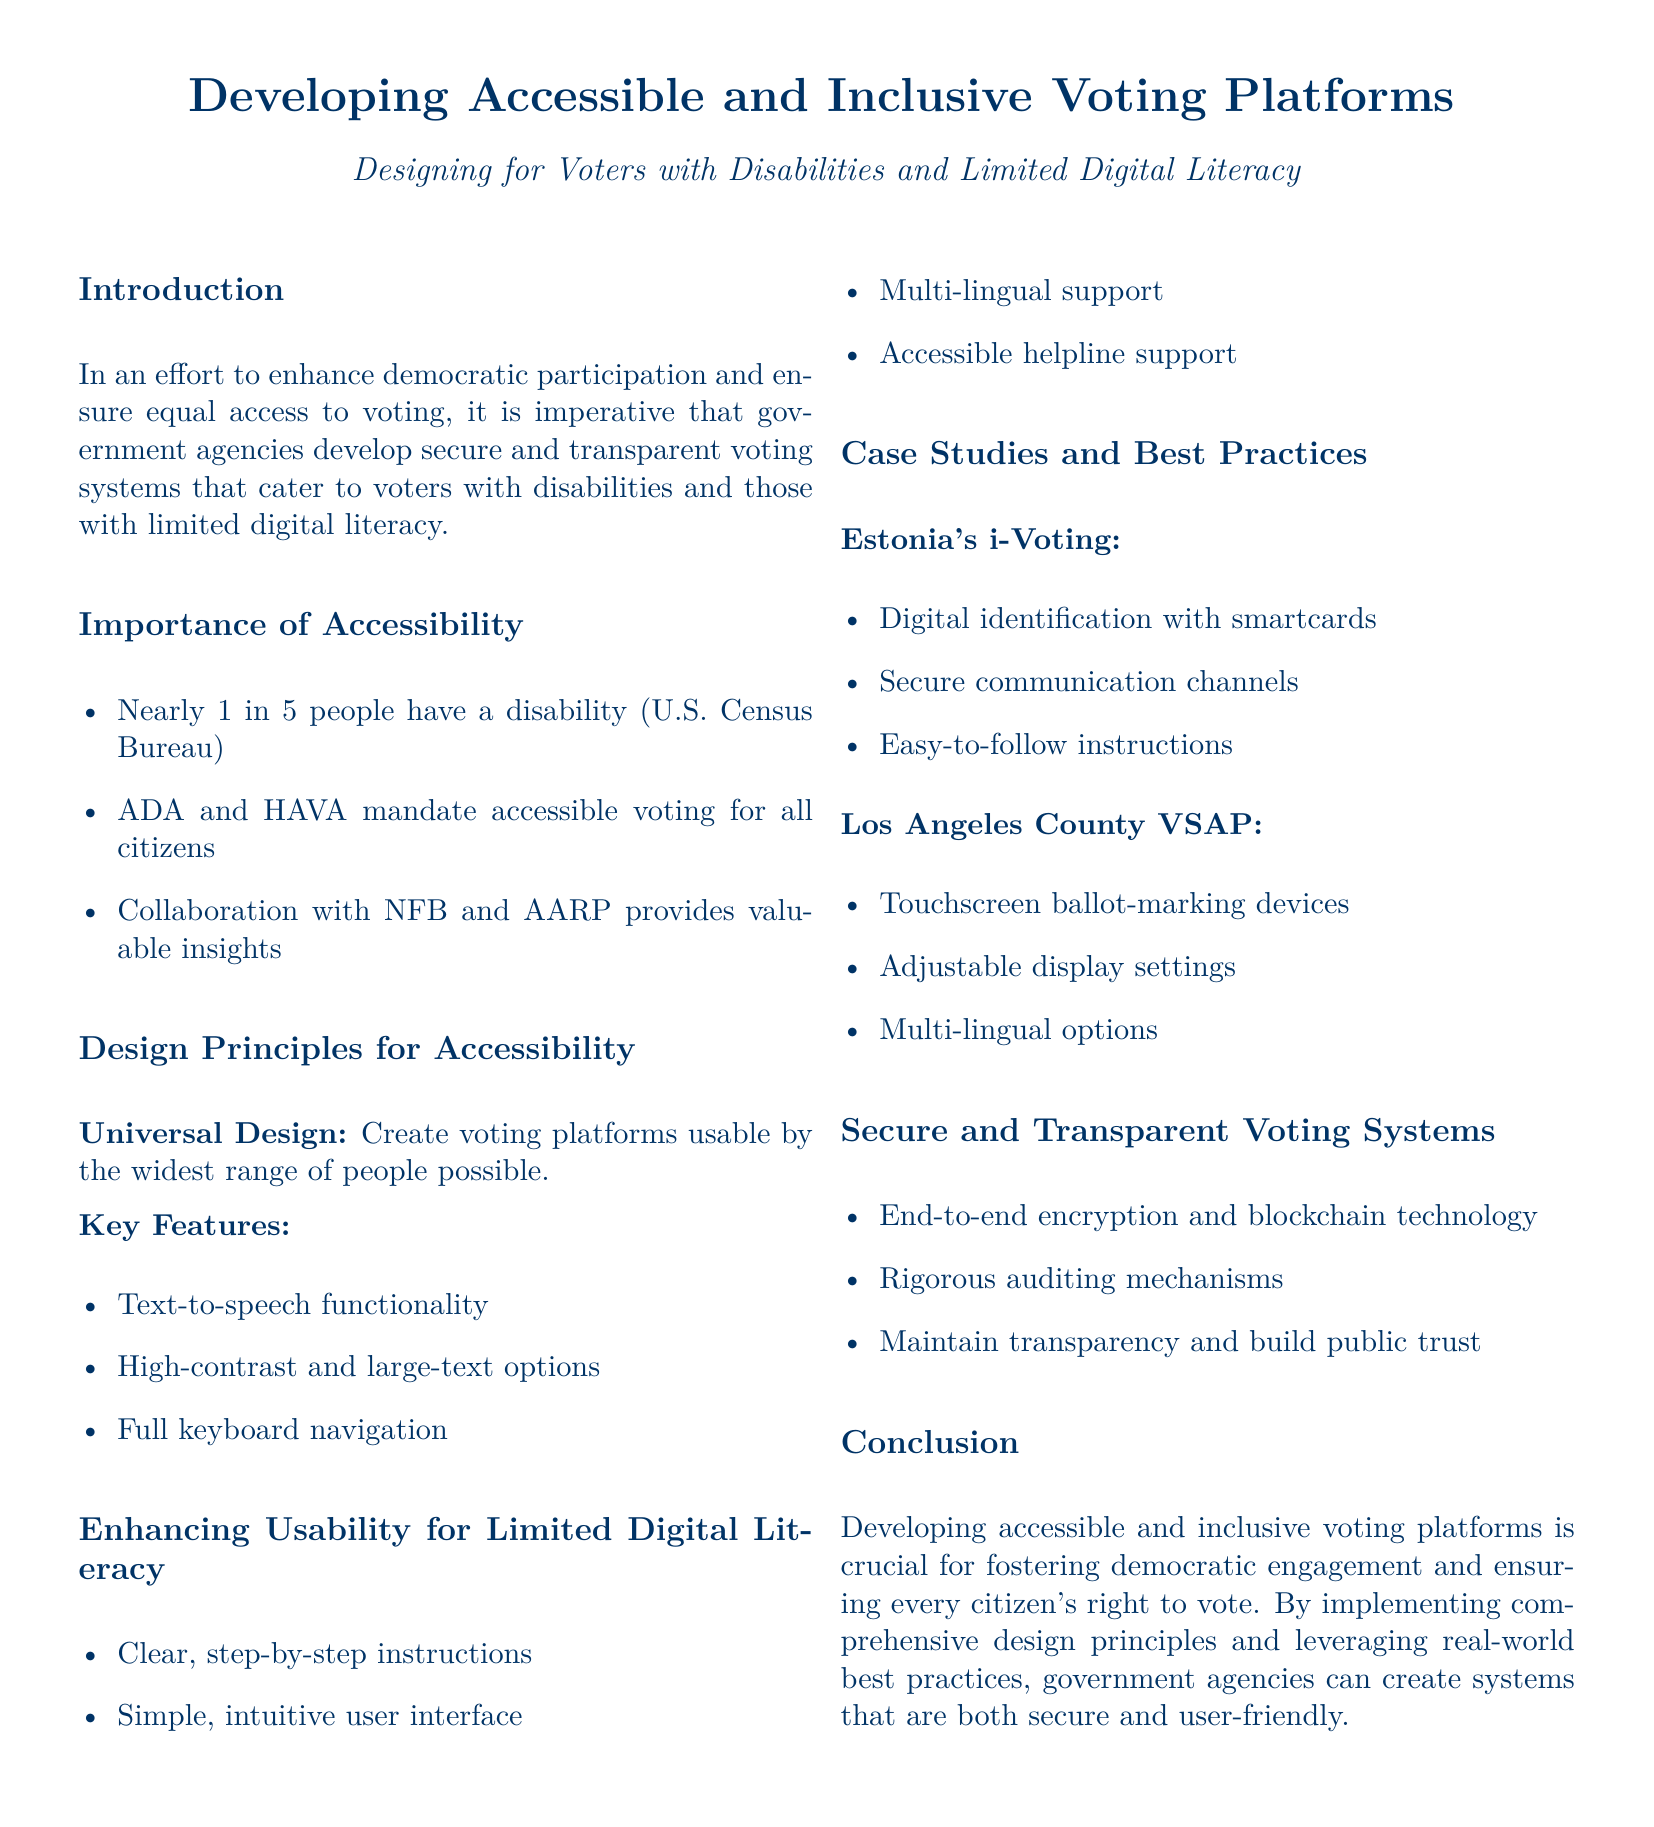what is the percentage of people with disabilities according to the U.S. Census Bureau? The document states that nearly 1 in 5 people have a disability, which implies approximately 20%.
Answer: 20% which legislation mandates accessible voting for all citizens? The document mentions ADA and HAVA as mandates for accessible voting.
Answer: ADA and HAVA what is one of the key features for accessibility in voting platforms? A key feature listed is text-to-speech functionality, aiding accessibility for users.
Answer: text-to-speech functionality what is the primary purpose of developing accessible voting platforms? The introduction states that the purpose is to enhance democratic participation and ensure equal access to voting.
Answer: enhance democratic participation which voting system is mentioned in relation to Estonia? The document refers to Estonia's i-Voting as a case study for accessible and secure voting.
Answer: i-Voting what type of support is recommended for enhancing usability for limited digital literacy? The document suggests providing accessible helpline support to assist users.
Answer: accessible helpline support how does Los Angeles County ensure adjustable settings in its voting system? The document notes that Los Angeles County's VSAP includes adjustable display settings for accessibility.
Answer: adjustable display settings which technology is highlighted for ensuring secure voting systems? The document mentions end-to-end encryption and blockchain technology as key to secure voting systems.
Answer: end-to-end encryption and blockchain technology what is the importance of collaboration mentioned in the document? The document states that collaboration with NFB and AARP provides valuable insights for developing accessible voting platforms.
Answer: valuable insights 